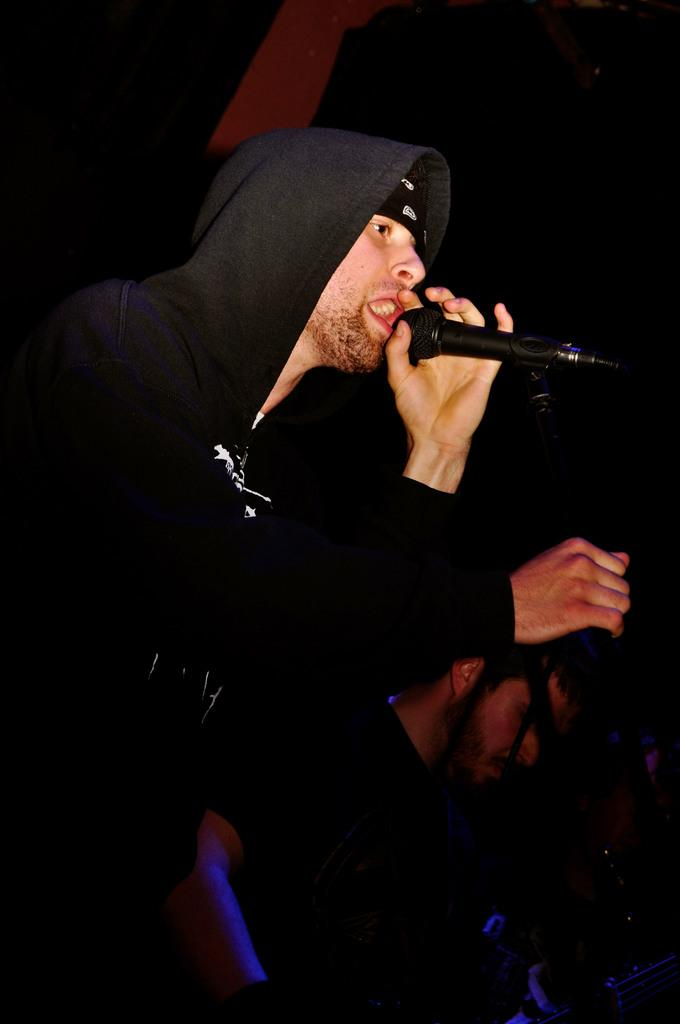What is the main subject of the image? There is a person in the image. What is the person doing in the image? The person is standing and holding a mic in his hand. What type of wood is being used to fuel the fire in the image? There is no fire or wood present in the image; it features a person standing and holding a mic. What is the person trying to stop in the image? There is no indication in the image that the person is trying to stop anything. 